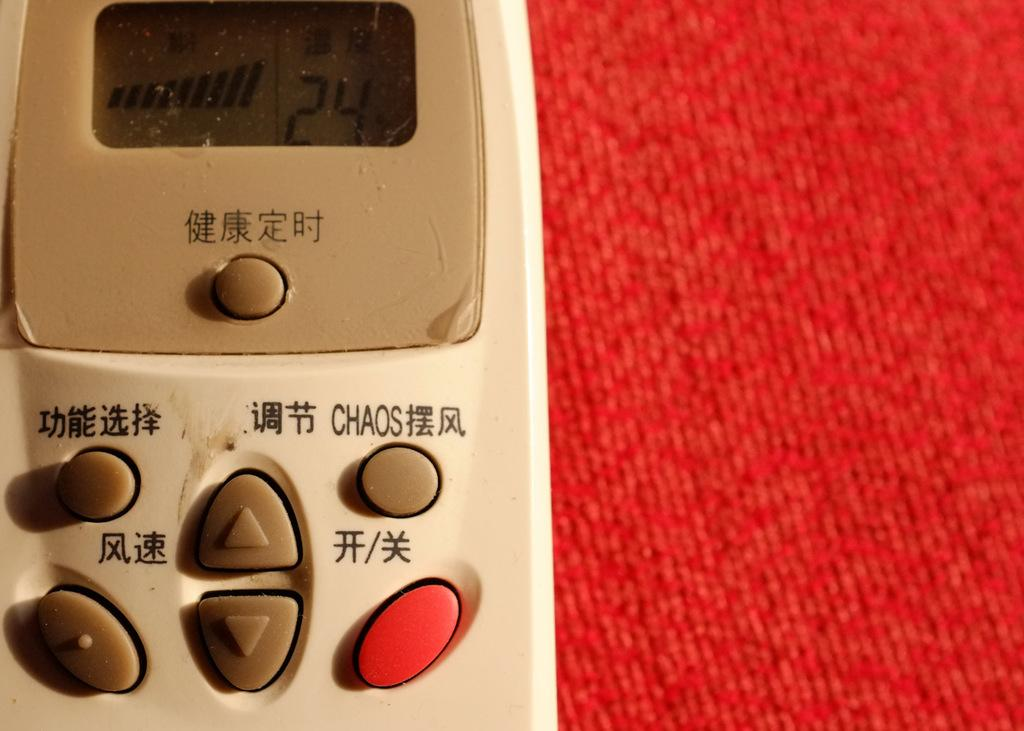<image>
Provide a brief description of the given image. A brown and beige remote control with a button that says chaos on the top right. 